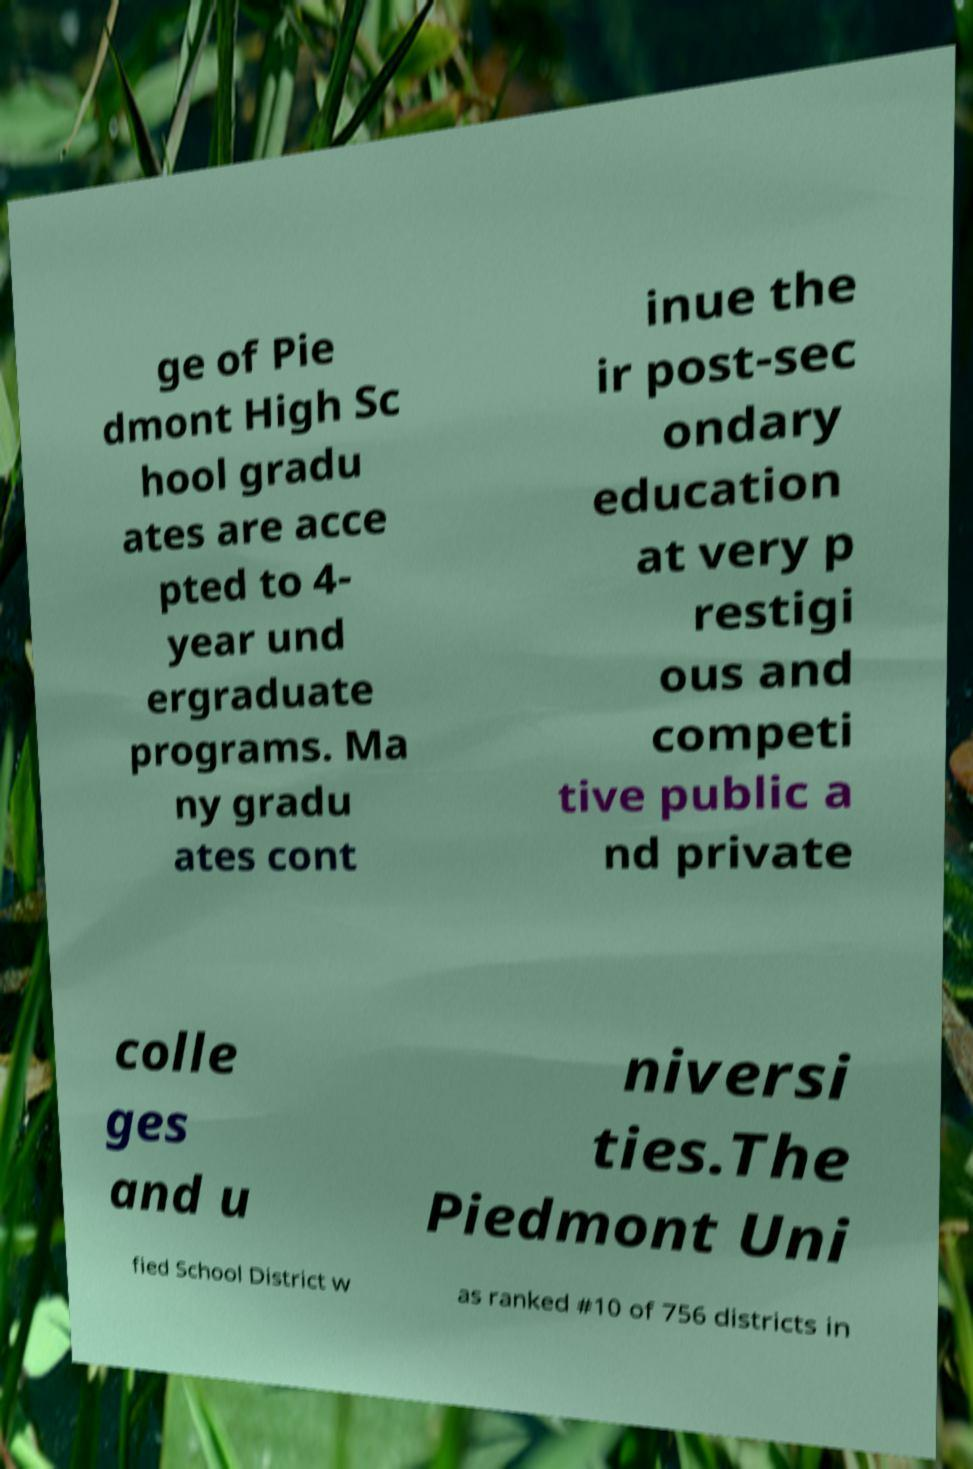Can you read and provide the text displayed in the image?This photo seems to have some interesting text. Can you extract and type it out for me? ge of Pie dmont High Sc hool gradu ates are acce pted to 4- year und ergraduate programs. Ma ny gradu ates cont inue the ir post-sec ondary education at very p restigi ous and competi tive public a nd private colle ges and u niversi ties.The Piedmont Uni fied School District w as ranked #10 of 756 districts in 